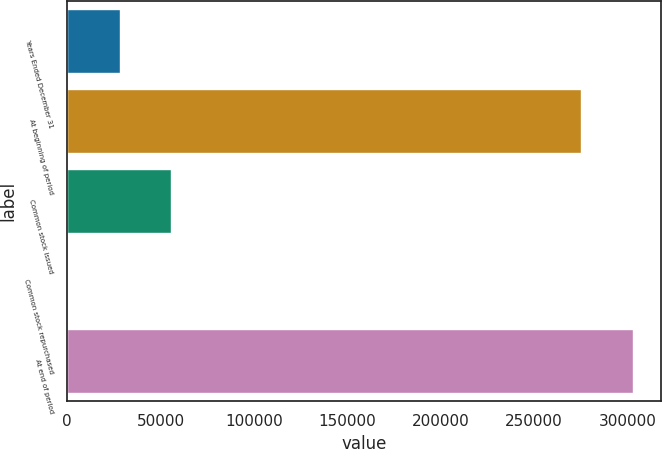<chart> <loc_0><loc_0><loc_500><loc_500><bar_chart><fcel>Years Ended December 31<fcel>At beginning of period<fcel>Common stock issued<fcel>Common stock repurchased<fcel>At end of period<nl><fcel>27991.7<fcel>275184<fcel>55677.4<fcel>306<fcel>302870<nl></chart> 